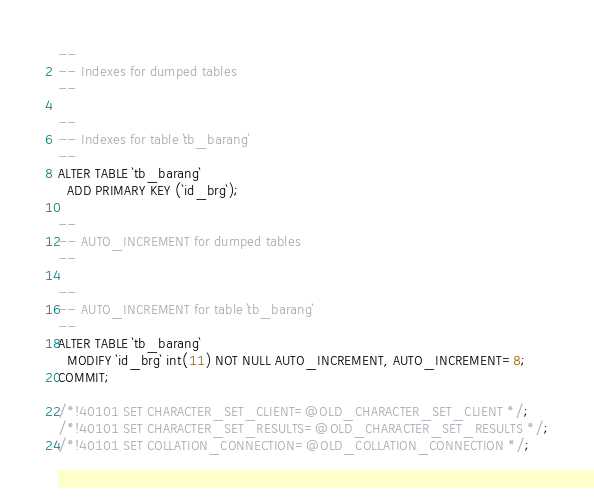<code> <loc_0><loc_0><loc_500><loc_500><_SQL_>
--
-- Indexes for dumped tables
--

--
-- Indexes for table `tb_barang`
--
ALTER TABLE `tb_barang`
  ADD PRIMARY KEY (`id_brg`);

--
-- AUTO_INCREMENT for dumped tables
--

--
-- AUTO_INCREMENT for table `tb_barang`
--
ALTER TABLE `tb_barang`
  MODIFY `id_brg` int(11) NOT NULL AUTO_INCREMENT, AUTO_INCREMENT=8;
COMMIT;

/*!40101 SET CHARACTER_SET_CLIENT=@OLD_CHARACTER_SET_CLIENT */;
/*!40101 SET CHARACTER_SET_RESULTS=@OLD_CHARACTER_SET_RESULTS */;
/*!40101 SET COLLATION_CONNECTION=@OLD_COLLATION_CONNECTION */;
</code> 